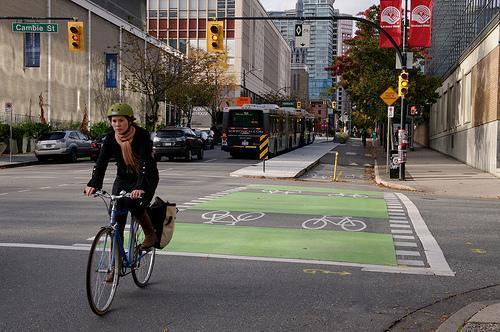How many traffic lights are shown?
Give a very brief answer. 3. How many buses are parked on the curb?
Give a very brief answer. 3. 